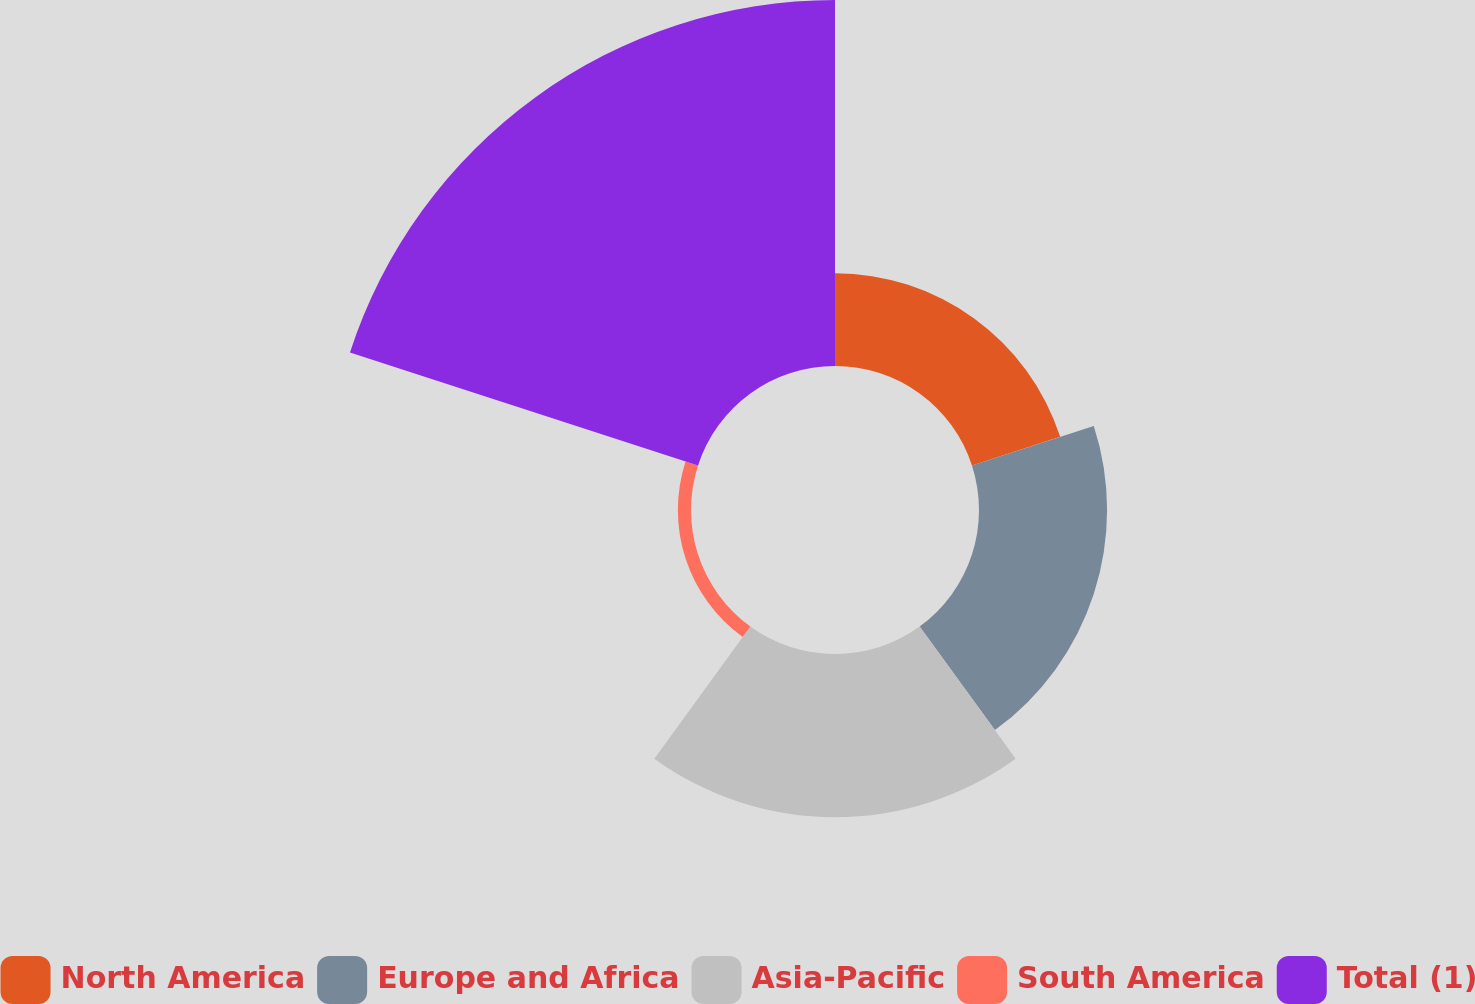Convert chart. <chart><loc_0><loc_0><loc_500><loc_500><pie_chart><fcel>North America<fcel>Europe and Africa<fcel>Asia-Pacific<fcel>South America<fcel>Total (1)<nl><fcel>12.15%<fcel>16.78%<fcel>21.4%<fcel>1.72%<fcel>47.95%<nl></chart> 